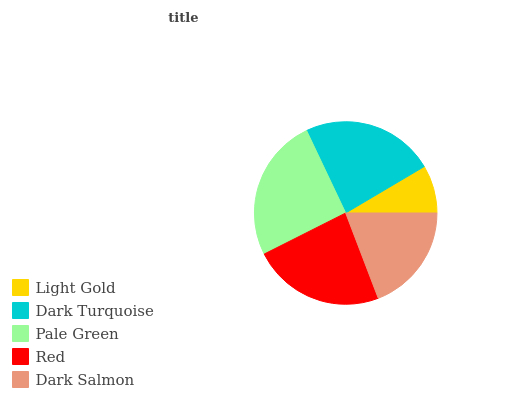Is Light Gold the minimum?
Answer yes or no. Yes. Is Pale Green the maximum?
Answer yes or no. Yes. Is Dark Turquoise the minimum?
Answer yes or no. No. Is Dark Turquoise the maximum?
Answer yes or no. No. Is Dark Turquoise greater than Light Gold?
Answer yes or no. Yes. Is Light Gold less than Dark Turquoise?
Answer yes or no. Yes. Is Light Gold greater than Dark Turquoise?
Answer yes or no. No. Is Dark Turquoise less than Light Gold?
Answer yes or no. No. Is Red the high median?
Answer yes or no. Yes. Is Red the low median?
Answer yes or no. Yes. Is Dark Salmon the high median?
Answer yes or no. No. Is Pale Green the low median?
Answer yes or no. No. 